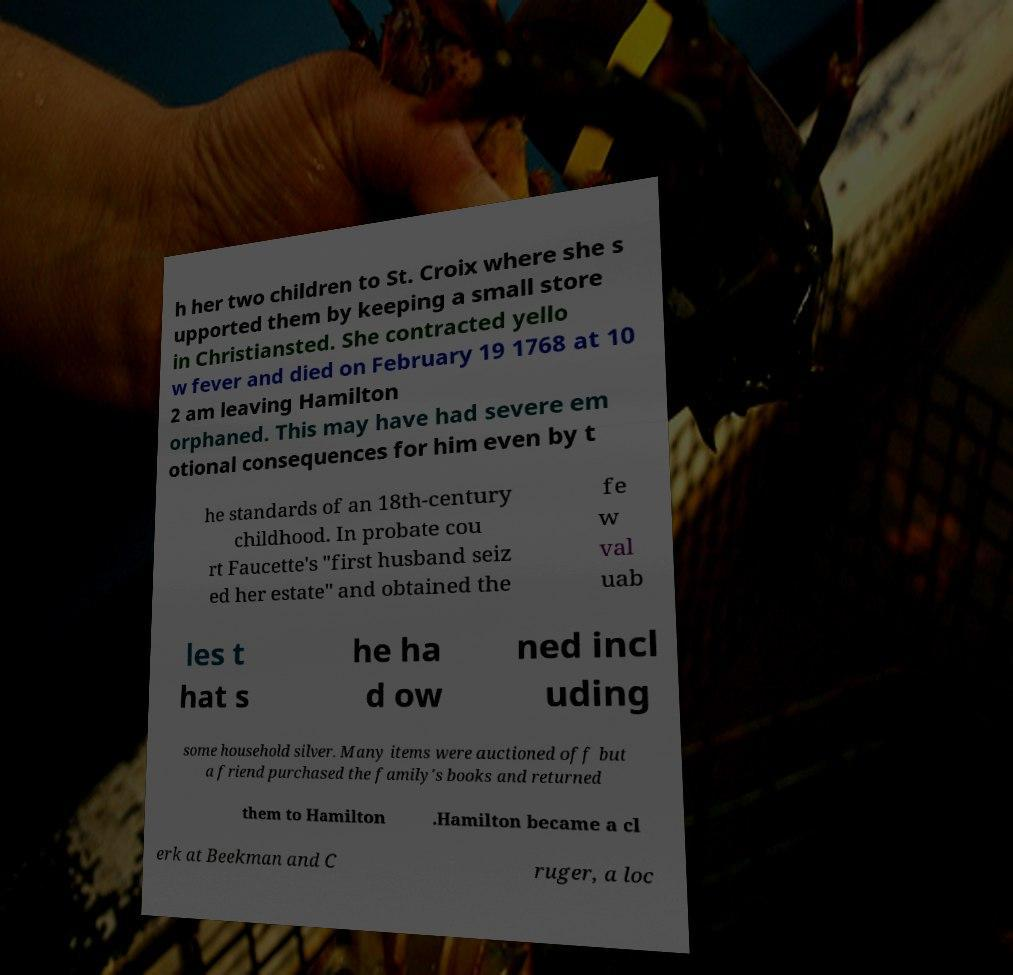There's text embedded in this image that I need extracted. Can you transcribe it verbatim? h her two children to St. Croix where she s upported them by keeping a small store in Christiansted. She contracted yello w fever and died on February 19 1768 at 10 2 am leaving Hamilton orphaned. This may have had severe em otional consequences for him even by t he standards of an 18th-century childhood. In probate cou rt Faucette's "first husband seiz ed her estate" and obtained the fe w val uab les t hat s he ha d ow ned incl uding some household silver. Many items were auctioned off but a friend purchased the family's books and returned them to Hamilton .Hamilton became a cl erk at Beekman and C ruger, a loc 